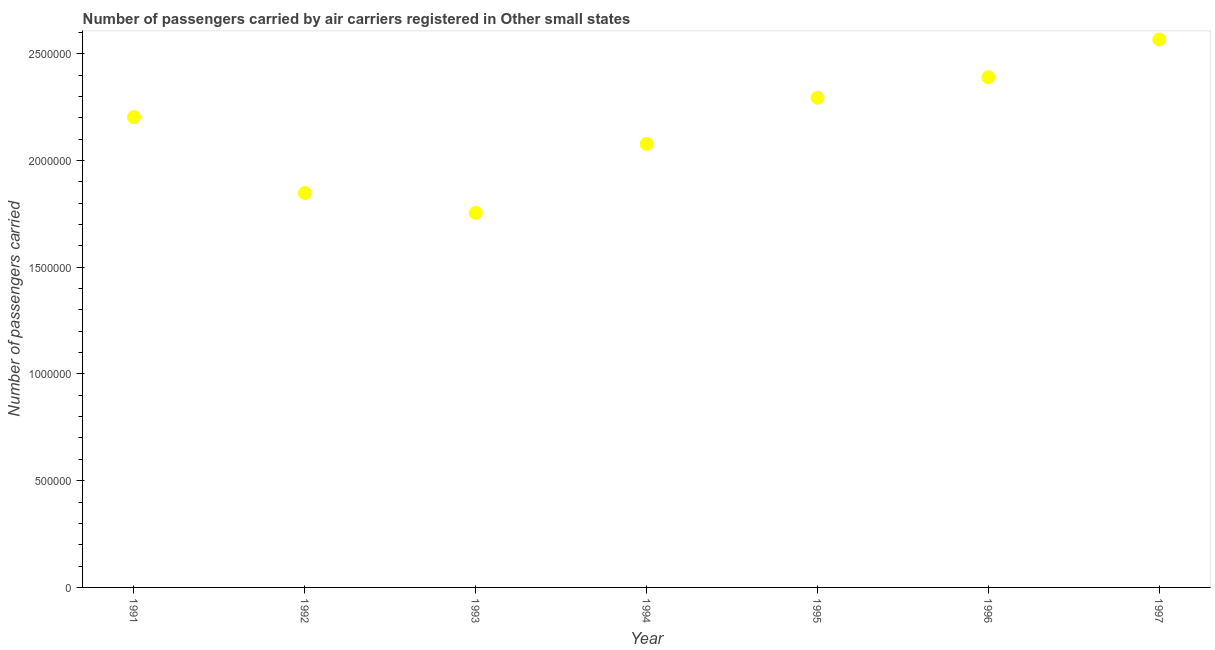What is the number of passengers carried in 1994?
Your response must be concise. 2.08e+06. Across all years, what is the maximum number of passengers carried?
Make the answer very short. 2.57e+06. Across all years, what is the minimum number of passengers carried?
Your answer should be very brief. 1.75e+06. In which year was the number of passengers carried maximum?
Your answer should be compact. 1997. In which year was the number of passengers carried minimum?
Offer a terse response. 1993. What is the sum of the number of passengers carried?
Give a very brief answer. 1.51e+07. What is the difference between the number of passengers carried in 1995 and 1996?
Ensure brevity in your answer.  -9.63e+04. What is the average number of passengers carried per year?
Offer a very short reply. 2.16e+06. What is the median number of passengers carried?
Give a very brief answer. 2.20e+06. Do a majority of the years between 1996 and 1992 (inclusive) have number of passengers carried greater than 1600000 ?
Keep it short and to the point. Yes. What is the ratio of the number of passengers carried in 1993 to that in 1994?
Your answer should be compact. 0.84. Is the number of passengers carried in 1996 less than that in 1997?
Ensure brevity in your answer.  Yes. Is the difference between the number of passengers carried in 1992 and 1996 greater than the difference between any two years?
Make the answer very short. No. What is the difference between the highest and the second highest number of passengers carried?
Give a very brief answer. 1.77e+05. Is the sum of the number of passengers carried in 1994 and 1996 greater than the maximum number of passengers carried across all years?
Your answer should be very brief. Yes. What is the difference between the highest and the lowest number of passengers carried?
Offer a terse response. 8.12e+05. Does the number of passengers carried monotonically increase over the years?
Ensure brevity in your answer.  No. What is the difference between two consecutive major ticks on the Y-axis?
Give a very brief answer. 5.00e+05. Are the values on the major ticks of Y-axis written in scientific E-notation?
Make the answer very short. No. Does the graph contain any zero values?
Give a very brief answer. No. Does the graph contain grids?
Your response must be concise. No. What is the title of the graph?
Your answer should be compact. Number of passengers carried by air carriers registered in Other small states. What is the label or title of the Y-axis?
Give a very brief answer. Number of passengers carried. What is the Number of passengers carried in 1991?
Offer a very short reply. 2.20e+06. What is the Number of passengers carried in 1992?
Offer a terse response. 1.85e+06. What is the Number of passengers carried in 1993?
Give a very brief answer. 1.75e+06. What is the Number of passengers carried in 1994?
Your response must be concise. 2.08e+06. What is the Number of passengers carried in 1995?
Your answer should be very brief. 2.29e+06. What is the Number of passengers carried in 1996?
Ensure brevity in your answer.  2.39e+06. What is the Number of passengers carried in 1997?
Your answer should be very brief. 2.57e+06. What is the difference between the Number of passengers carried in 1991 and 1992?
Your answer should be compact. 3.56e+05. What is the difference between the Number of passengers carried in 1991 and 1993?
Give a very brief answer. 4.49e+05. What is the difference between the Number of passengers carried in 1991 and 1994?
Your answer should be very brief. 1.26e+05. What is the difference between the Number of passengers carried in 1991 and 1995?
Keep it short and to the point. -9.07e+04. What is the difference between the Number of passengers carried in 1991 and 1996?
Offer a very short reply. -1.87e+05. What is the difference between the Number of passengers carried in 1991 and 1997?
Your answer should be very brief. -3.64e+05. What is the difference between the Number of passengers carried in 1992 and 1993?
Give a very brief answer. 9.30e+04. What is the difference between the Number of passengers carried in 1992 and 1994?
Give a very brief answer. -2.30e+05. What is the difference between the Number of passengers carried in 1992 and 1995?
Your answer should be compact. -4.46e+05. What is the difference between the Number of passengers carried in 1992 and 1996?
Offer a very short reply. -5.43e+05. What is the difference between the Number of passengers carried in 1992 and 1997?
Ensure brevity in your answer.  -7.19e+05. What is the difference between the Number of passengers carried in 1993 and 1994?
Your answer should be very brief. -3.23e+05. What is the difference between the Number of passengers carried in 1993 and 1995?
Make the answer very short. -5.39e+05. What is the difference between the Number of passengers carried in 1993 and 1996?
Offer a terse response. -6.36e+05. What is the difference between the Number of passengers carried in 1993 and 1997?
Keep it short and to the point. -8.12e+05. What is the difference between the Number of passengers carried in 1994 and 1995?
Offer a very short reply. -2.16e+05. What is the difference between the Number of passengers carried in 1994 and 1996?
Offer a very short reply. -3.13e+05. What is the difference between the Number of passengers carried in 1994 and 1997?
Offer a terse response. -4.89e+05. What is the difference between the Number of passengers carried in 1995 and 1996?
Keep it short and to the point. -9.63e+04. What is the difference between the Number of passengers carried in 1995 and 1997?
Keep it short and to the point. -2.73e+05. What is the difference between the Number of passengers carried in 1996 and 1997?
Your answer should be compact. -1.77e+05. What is the ratio of the Number of passengers carried in 1991 to that in 1992?
Your response must be concise. 1.19. What is the ratio of the Number of passengers carried in 1991 to that in 1993?
Your answer should be compact. 1.26. What is the ratio of the Number of passengers carried in 1991 to that in 1994?
Offer a very short reply. 1.06. What is the ratio of the Number of passengers carried in 1991 to that in 1996?
Keep it short and to the point. 0.92. What is the ratio of the Number of passengers carried in 1991 to that in 1997?
Provide a short and direct response. 0.86. What is the ratio of the Number of passengers carried in 1992 to that in 1993?
Offer a very short reply. 1.05. What is the ratio of the Number of passengers carried in 1992 to that in 1994?
Provide a short and direct response. 0.89. What is the ratio of the Number of passengers carried in 1992 to that in 1995?
Keep it short and to the point. 0.81. What is the ratio of the Number of passengers carried in 1992 to that in 1996?
Give a very brief answer. 0.77. What is the ratio of the Number of passengers carried in 1992 to that in 1997?
Ensure brevity in your answer.  0.72. What is the ratio of the Number of passengers carried in 1993 to that in 1994?
Offer a terse response. 0.84. What is the ratio of the Number of passengers carried in 1993 to that in 1995?
Provide a short and direct response. 0.77. What is the ratio of the Number of passengers carried in 1993 to that in 1996?
Give a very brief answer. 0.73. What is the ratio of the Number of passengers carried in 1993 to that in 1997?
Make the answer very short. 0.68. What is the ratio of the Number of passengers carried in 1994 to that in 1995?
Offer a very short reply. 0.91. What is the ratio of the Number of passengers carried in 1994 to that in 1996?
Your answer should be compact. 0.87. What is the ratio of the Number of passengers carried in 1994 to that in 1997?
Ensure brevity in your answer.  0.81. What is the ratio of the Number of passengers carried in 1995 to that in 1997?
Give a very brief answer. 0.89. What is the ratio of the Number of passengers carried in 1996 to that in 1997?
Provide a short and direct response. 0.93. 